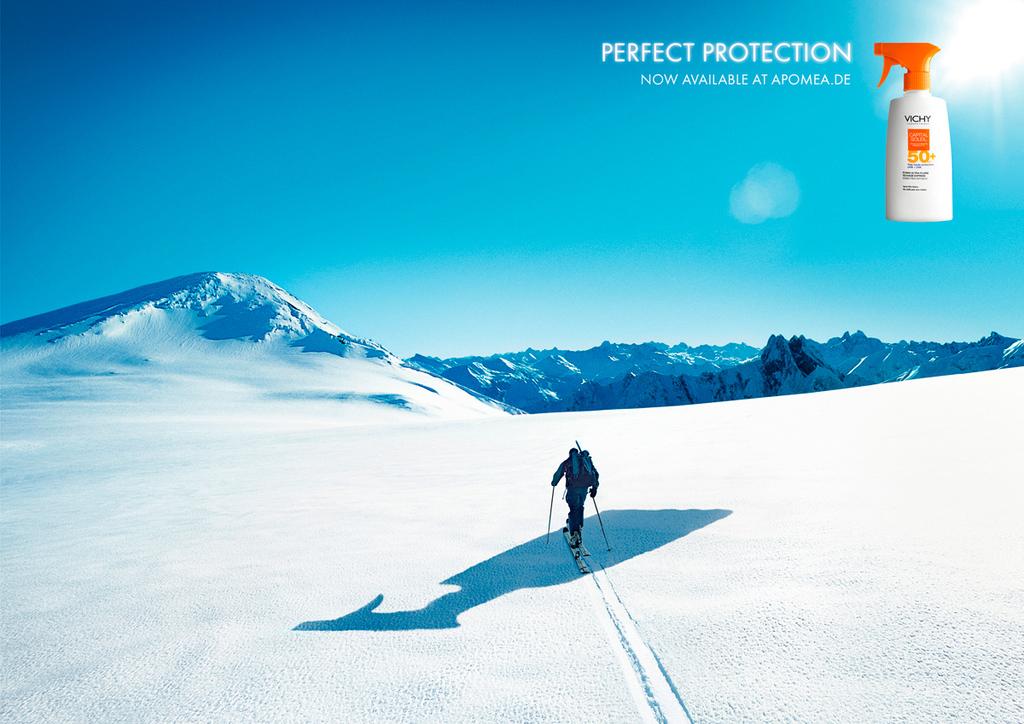Where is this spray available?
Provide a short and direct response. Apomea.de. What kind of protection?
Give a very brief answer. Perfect. 